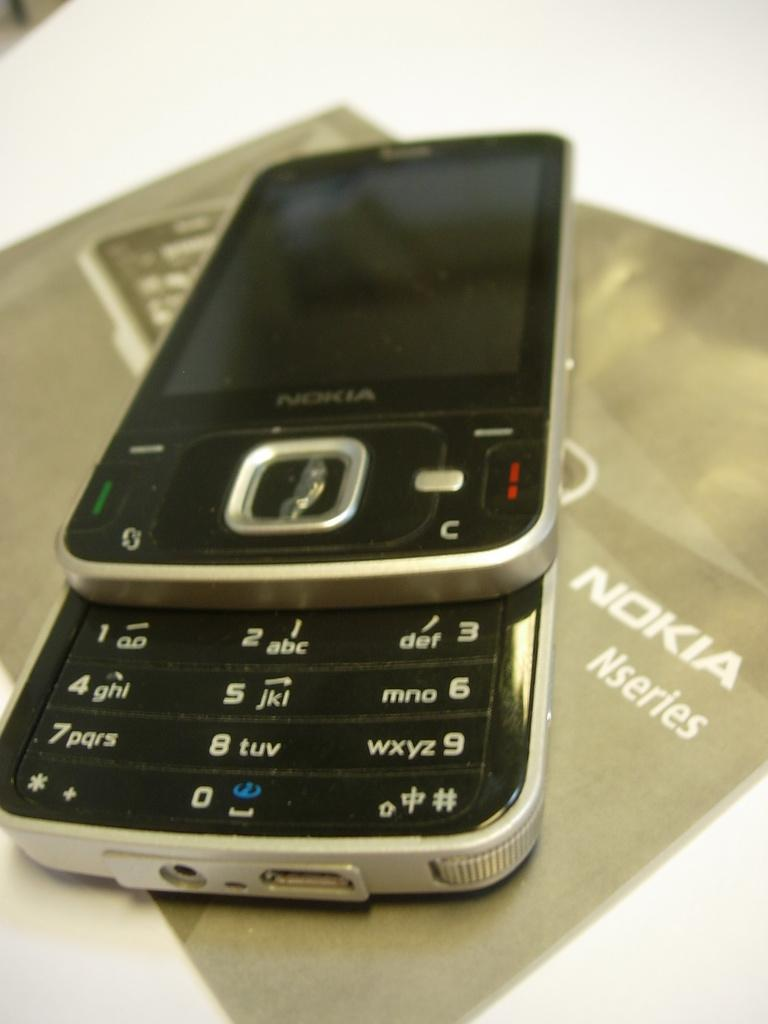What is the main object in the image? There is a mobile in the image. What other object is present in the image? There is a paper in the image. Where are the mobile and the paper located? Both the mobile and the paper are placed on a table. What type of cow can be seen grazing on the bait in the image? There is no cow or bait present in the image. What shape is the mobile in the image? The provided facts do not mention the shape of the mobile, so we cannot determine its shape from the information given. 